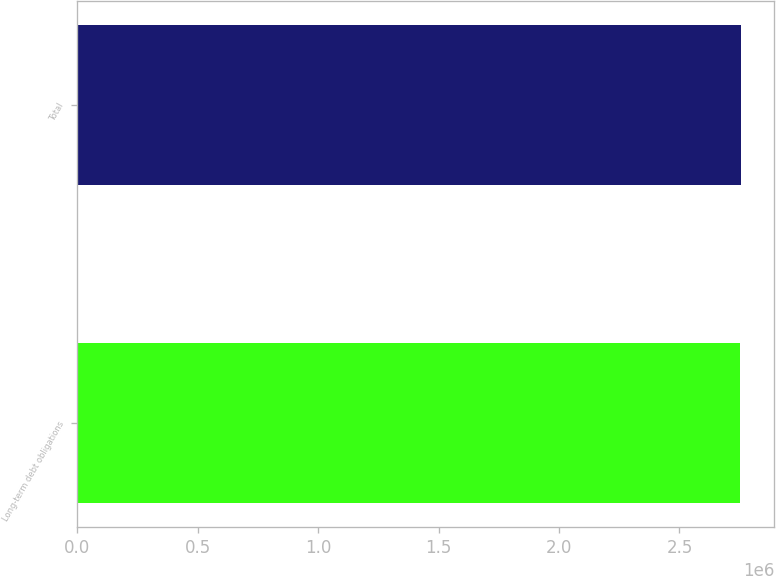Convert chart. <chart><loc_0><loc_0><loc_500><loc_500><bar_chart><fcel>Long-term debt obligations<fcel>Total<nl><fcel>2.75151e+06<fcel>2.75575e+06<nl></chart> 